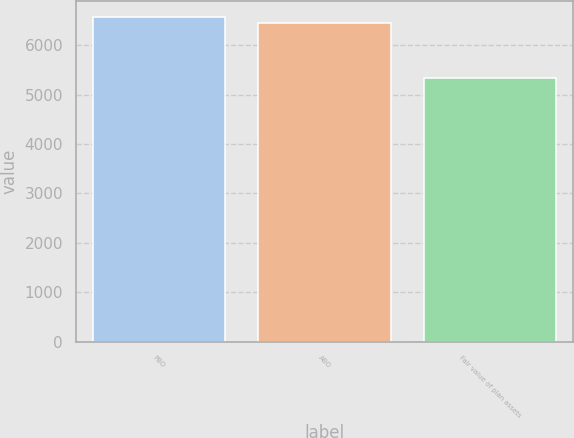<chart> <loc_0><loc_0><loc_500><loc_500><bar_chart><fcel>PBO<fcel>ABO<fcel>Fair value of plan assets<nl><fcel>6562.3<fcel>6440<fcel>5335<nl></chart> 